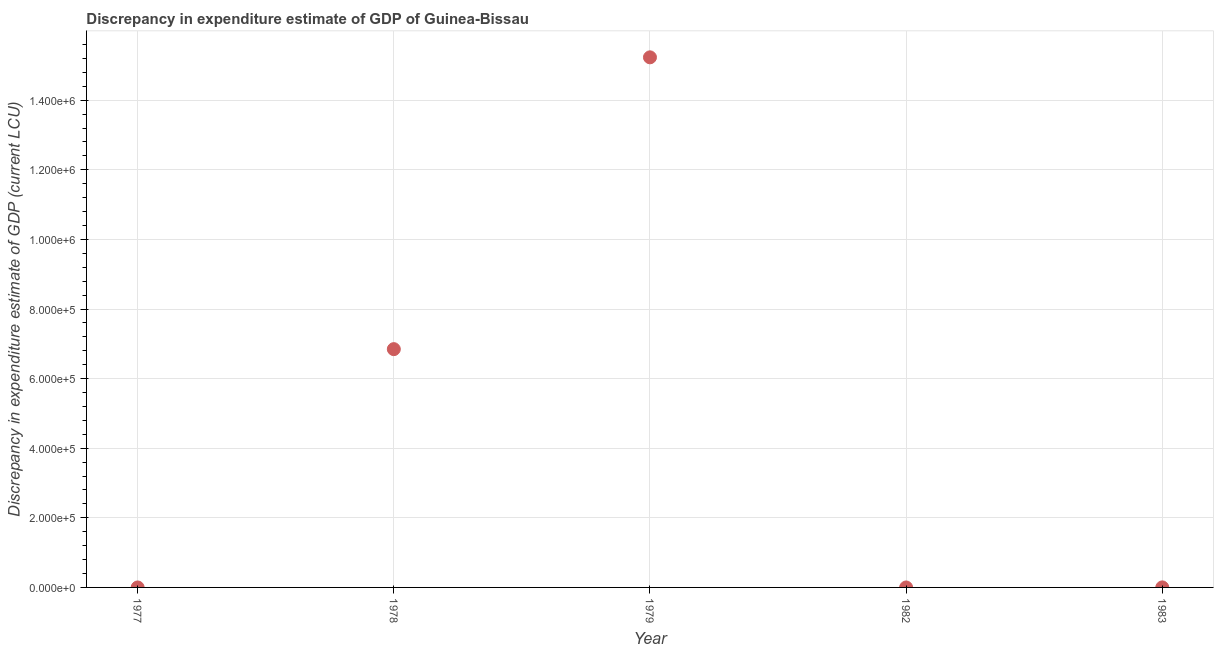Across all years, what is the maximum discrepancy in expenditure estimate of gdp?
Provide a short and direct response. 1.52e+06. In which year was the discrepancy in expenditure estimate of gdp maximum?
Your answer should be very brief. 1979. What is the sum of the discrepancy in expenditure estimate of gdp?
Ensure brevity in your answer.  2.21e+06. What is the difference between the discrepancy in expenditure estimate of gdp in 1978 and 1979?
Keep it short and to the point. -8.38e+05. What is the average discrepancy in expenditure estimate of gdp per year?
Your response must be concise. 4.42e+05. What is the median discrepancy in expenditure estimate of gdp?
Give a very brief answer. 100. In how many years, is the discrepancy in expenditure estimate of gdp greater than 1240000 LCU?
Your answer should be compact. 1. What is the ratio of the discrepancy in expenditure estimate of gdp in 1979 to that in 1983?
Provide a succinct answer. 1.52e+04. Is the discrepancy in expenditure estimate of gdp in 1979 less than that in 1983?
Make the answer very short. No. What is the difference between the highest and the second highest discrepancy in expenditure estimate of gdp?
Offer a terse response. 8.38e+05. Is the sum of the discrepancy in expenditure estimate of gdp in 1979 and 1983 greater than the maximum discrepancy in expenditure estimate of gdp across all years?
Offer a terse response. Yes. What is the difference between the highest and the lowest discrepancy in expenditure estimate of gdp?
Your response must be concise. 1.52e+06. How many dotlines are there?
Make the answer very short. 1. How many years are there in the graph?
Keep it short and to the point. 5. What is the difference between two consecutive major ticks on the Y-axis?
Your answer should be compact. 2.00e+05. What is the title of the graph?
Keep it short and to the point. Discrepancy in expenditure estimate of GDP of Guinea-Bissau. What is the label or title of the Y-axis?
Give a very brief answer. Discrepancy in expenditure estimate of GDP (current LCU). What is the Discrepancy in expenditure estimate of GDP (current LCU) in 1977?
Offer a terse response. 0. What is the Discrepancy in expenditure estimate of GDP (current LCU) in 1978?
Make the answer very short. 6.85e+05. What is the Discrepancy in expenditure estimate of GDP (current LCU) in 1979?
Provide a succinct answer. 1.52e+06. What is the Discrepancy in expenditure estimate of GDP (current LCU) in 1982?
Your response must be concise. 0. What is the difference between the Discrepancy in expenditure estimate of GDP (current LCU) in 1978 and 1979?
Offer a very short reply. -8.38e+05. What is the difference between the Discrepancy in expenditure estimate of GDP (current LCU) in 1978 and 1983?
Give a very brief answer. 6.85e+05. What is the difference between the Discrepancy in expenditure estimate of GDP (current LCU) in 1979 and 1983?
Give a very brief answer. 1.52e+06. What is the ratio of the Discrepancy in expenditure estimate of GDP (current LCU) in 1978 to that in 1979?
Give a very brief answer. 0.45. What is the ratio of the Discrepancy in expenditure estimate of GDP (current LCU) in 1978 to that in 1983?
Make the answer very short. 6847. What is the ratio of the Discrepancy in expenditure estimate of GDP (current LCU) in 1979 to that in 1983?
Keep it short and to the point. 1.52e+04. 